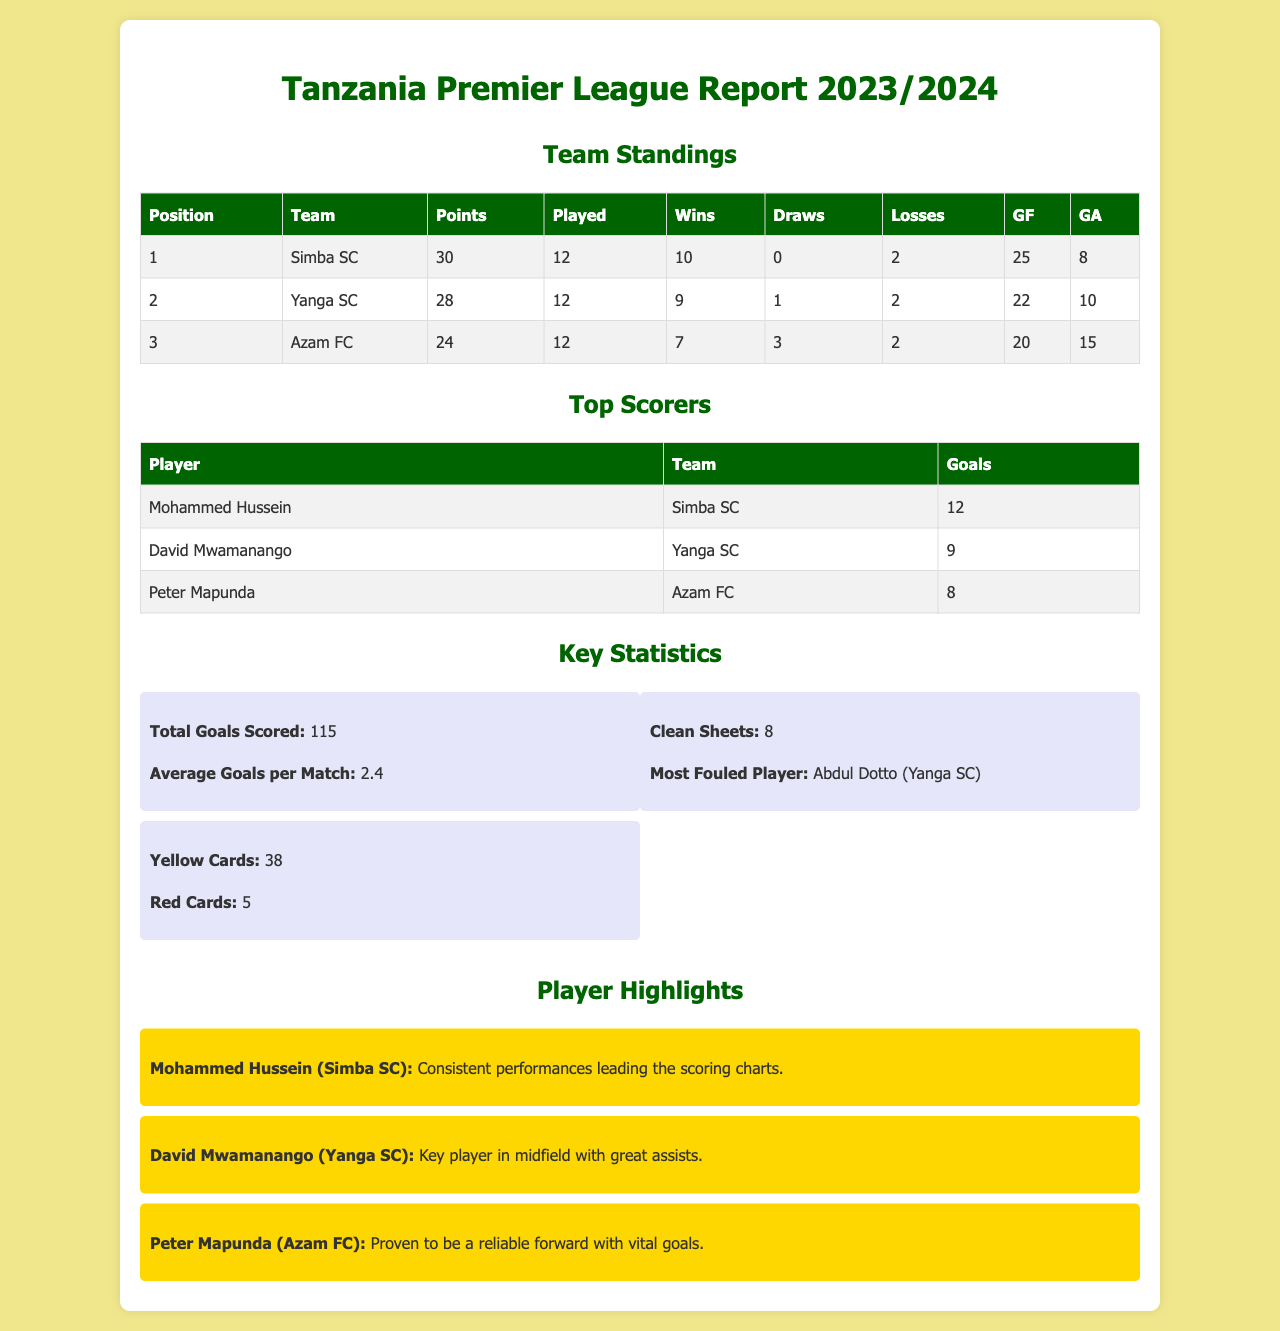What team is in first place? The first place team as per the standings is listed clearly in the report.
Answer: Simba SC How many goals has Mohammed Hussein scored? The document records player statistics, including the number of goals for top scorers.
Answer: 12 What is the average goals per match? The document provides key statistics, including the average goals scored per match.
Answer: 2.4 Who is the most fouled player? Key player statistics are listed, revealing who has been most frequently fouled.
Answer: Abdul Dotto What is the total number of clean sheets recorded? The document presents total key statistics including clean sheets by teams or players.
Answer: 8 How many points does Yanga SC have? The standing table gives points per team, thus easily identifiable for each.
Answer: 28 